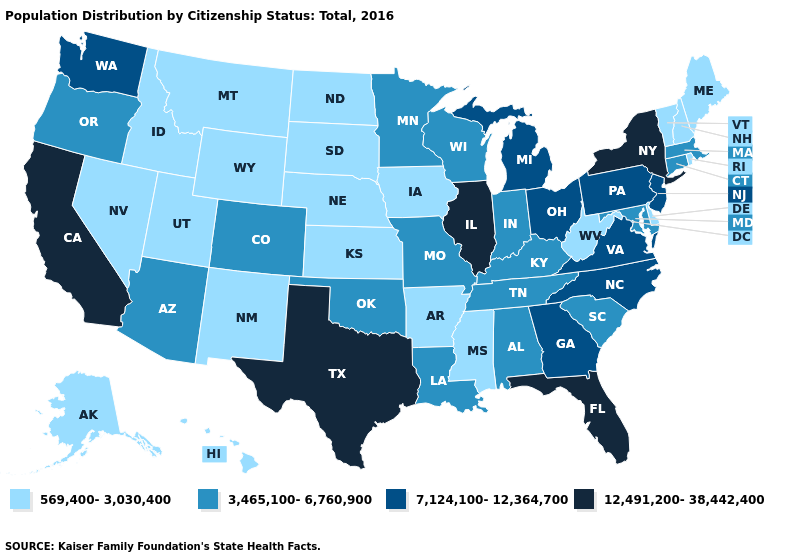Is the legend a continuous bar?
Keep it brief. No. What is the lowest value in the USA?
Give a very brief answer. 569,400-3,030,400. What is the highest value in states that border Oklahoma?
Short answer required. 12,491,200-38,442,400. What is the value of Colorado?
Quick response, please. 3,465,100-6,760,900. What is the value of Florida?
Write a very short answer. 12,491,200-38,442,400. What is the lowest value in states that border Georgia?
Concise answer only. 3,465,100-6,760,900. Name the states that have a value in the range 7,124,100-12,364,700?
Short answer required. Georgia, Michigan, New Jersey, North Carolina, Ohio, Pennsylvania, Virginia, Washington. How many symbols are there in the legend?
Be succinct. 4. What is the value of New Jersey?
Be succinct. 7,124,100-12,364,700. Does Maine have the lowest value in the Northeast?
Write a very short answer. Yes. Which states have the lowest value in the USA?
Give a very brief answer. Alaska, Arkansas, Delaware, Hawaii, Idaho, Iowa, Kansas, Maine, Mississippi, Montana, Nebraska, Nevada, New Hampshire, New Mexico, North Dakota, Rhode Island, South Dakota, Utah, Vermont, West Virginia, Wyoming. Name the states that have a value in the range 12,491,200-38,442,400?
Be succinct. California, Florida, Illinois, New York, Texas. What is the highest value in the MidWest ?
Short answer required. 12,491,200-38,442,400. What is the highest value in the USA?
Be succinct. 12,491,200-38,442,400. Does South Carolina have a higher value than New Hampshire?
Short answer required. Yes. 